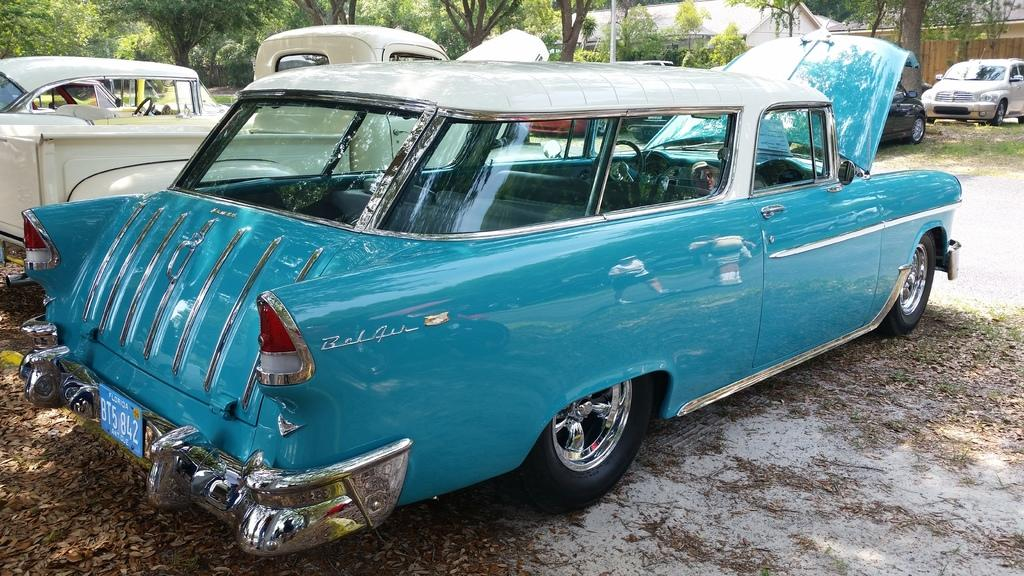What is happening on the road in the image? There are vehicles on the road in the image. Can you describe one of the vehicles? One of the vehicles is blue. What can be seen in the background of the image? There are houses and trees with green color in the background of the image. What type of jeans is the tree wearing in the image? There are no jeans present in the image, as trees do not wear clothing. 